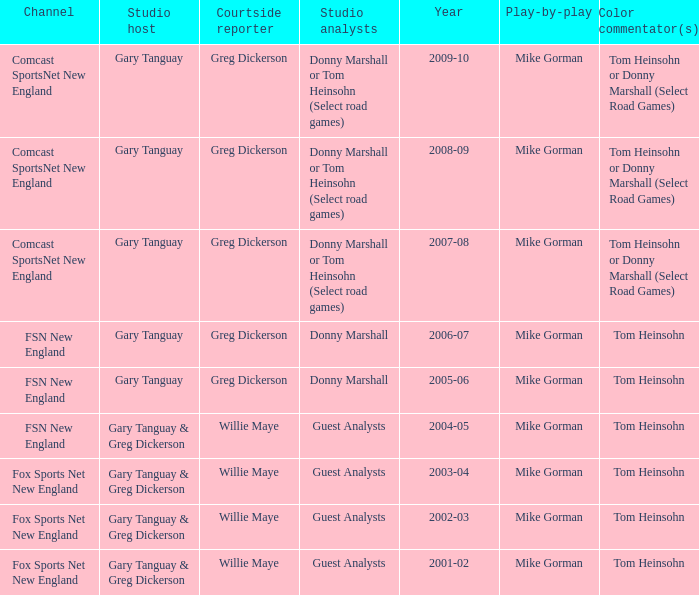How many channels were the games shown on in 2001-02? 1.0. 